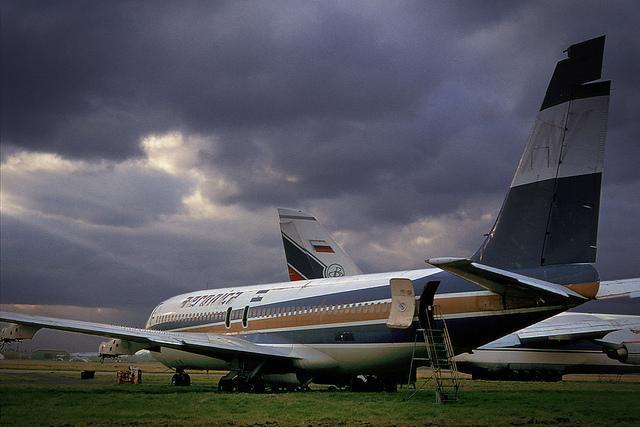How many planes?
Give a very brief answer. 2. How many airplanes can you see?
Give a very brief answer. 2. How many people are on the boat not at the dock?
Give a very brief answer. 0. 